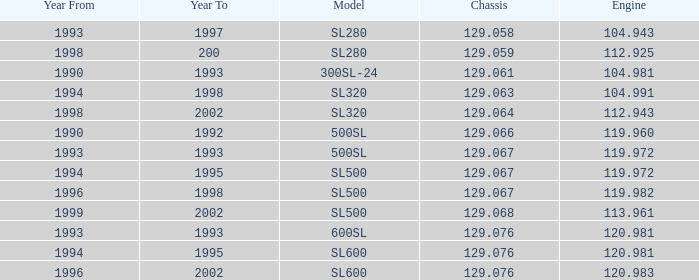Which Engine has a Model of sl500, and a Chassis smaller than 129.067? None. 